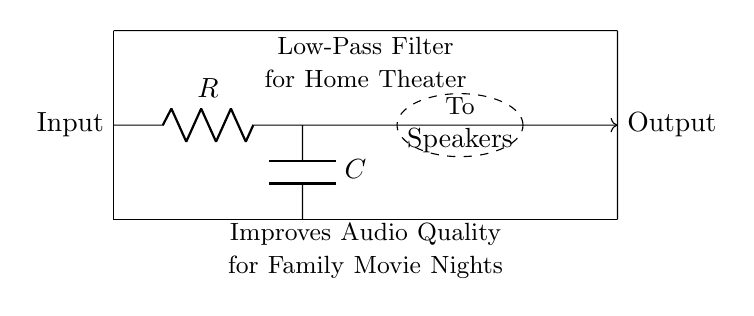What are the components in this circuit? The circuit includes a resistor and a capacitor, which are necessary for forming the low-pass filter. The resistor is labeled 'R' and the capacitor is labeled 'C'.
Answer: Resistor and capacitor What is the function of the resistor in this circuit? The resistor limits the current flowing through the circuit, which is essential for controlling the time constant of the filter and its cutoff frequency.
Answer: Current limiter What does the output in this circuit connect to? The output connects to the speakers, which is indicated by the dashed ellipse labeled "To Speakers" in the diagram.
Answer: Speakers What is the main purpose of this low-pass filter? The low-pass filter is designed to improve audio quality during movie nights by allowing low-frequency signals to pass while attenuating higher frequencies.
Answer: Improve audio quality What happens to high-frequency signals in this circuit? High-frequency signals are attenuated, meaning they are reduced in amplitude and do not reach the output, resulting in clearer sound for the intended frequencies.
Answer: Attenuated What is the input signal in this circuit? The input signal is the audio signal from the source, as indicated at the left side of the circuit diagram labeled "Input".
Answer: Audio signal What would happen if the capacitor value is increased? Increasing the capacitor value would lower the cutoff frequency of the filter, allowing more low-frequency signals to pass and further improving the audio quality for bass sounds.
Answer: Lower cutoff frequency 